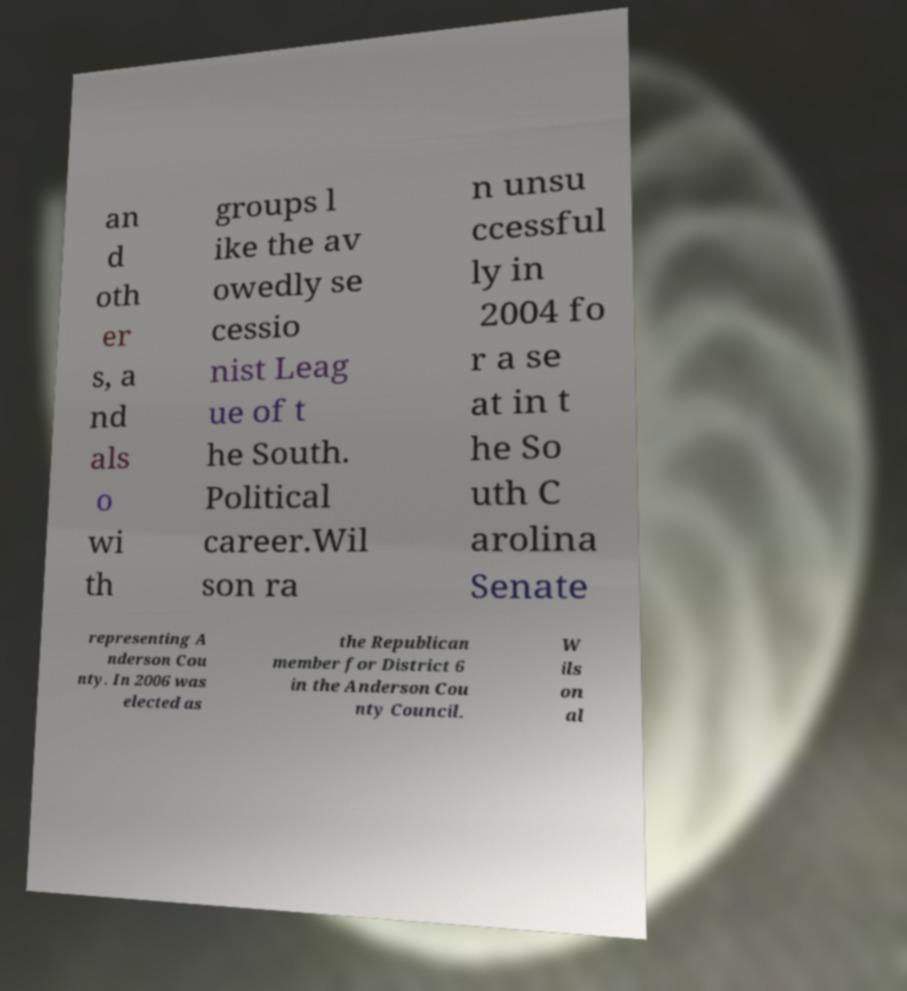There's text embedded in this image that I need extracted. Can you transcribe it verbatim? an d oth er s, a nd als o wi th groups l ike the av owedly se cessio nist Leag ue of t he South. Political career.Wil son ra n unsu ccessful ly in 2004 fo r a se at in t he So uth C arolina Senate representing A nderson Cou nty. In 2006 was elected as the Republican member for District 6 in the Anderson Cou nty Council. W ils on al 